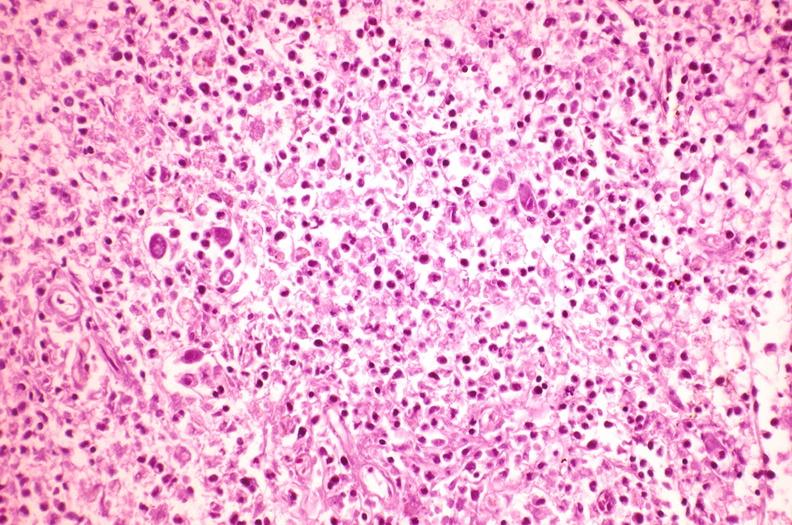what does this image show?
Answer the question using a single word or phrase. Spleen 